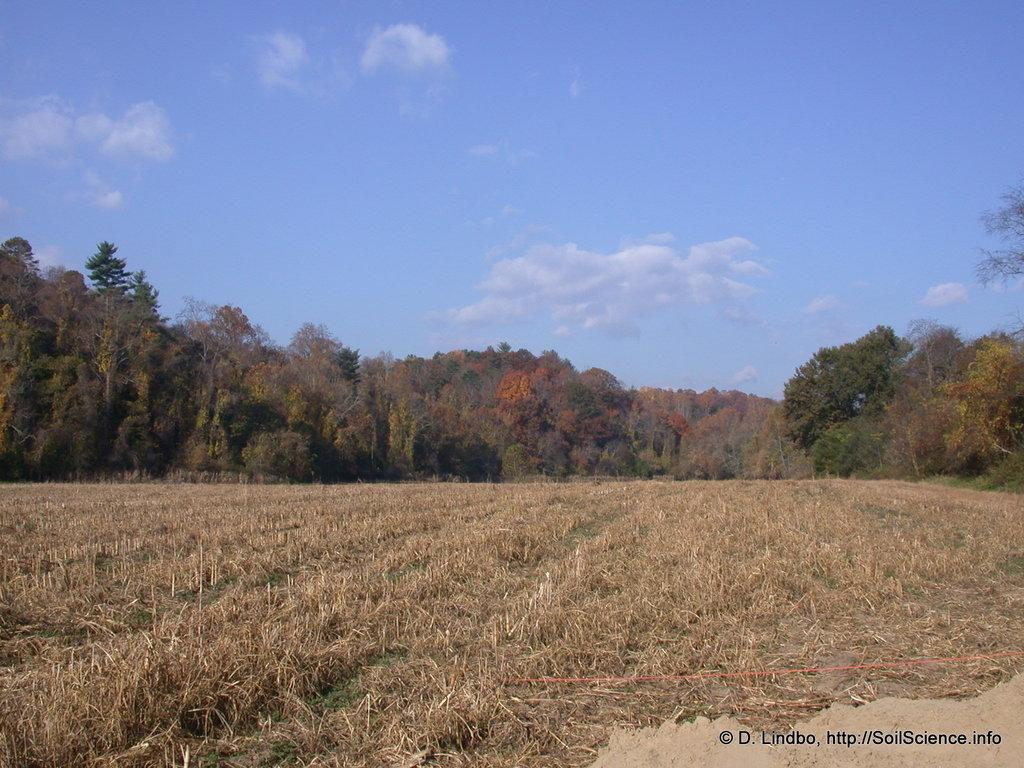What type of landscape is depicted in the picture? There is a farm field in the picture. What other natural elements can be seen in the image? There are trees in the picture. What is visible in the sky in the image? There are clouds visible in the sky. How many icicles are hanging from the trees in the image? There are no icicles present in the image, as it is a farm field with trees and clouds in the sky. 